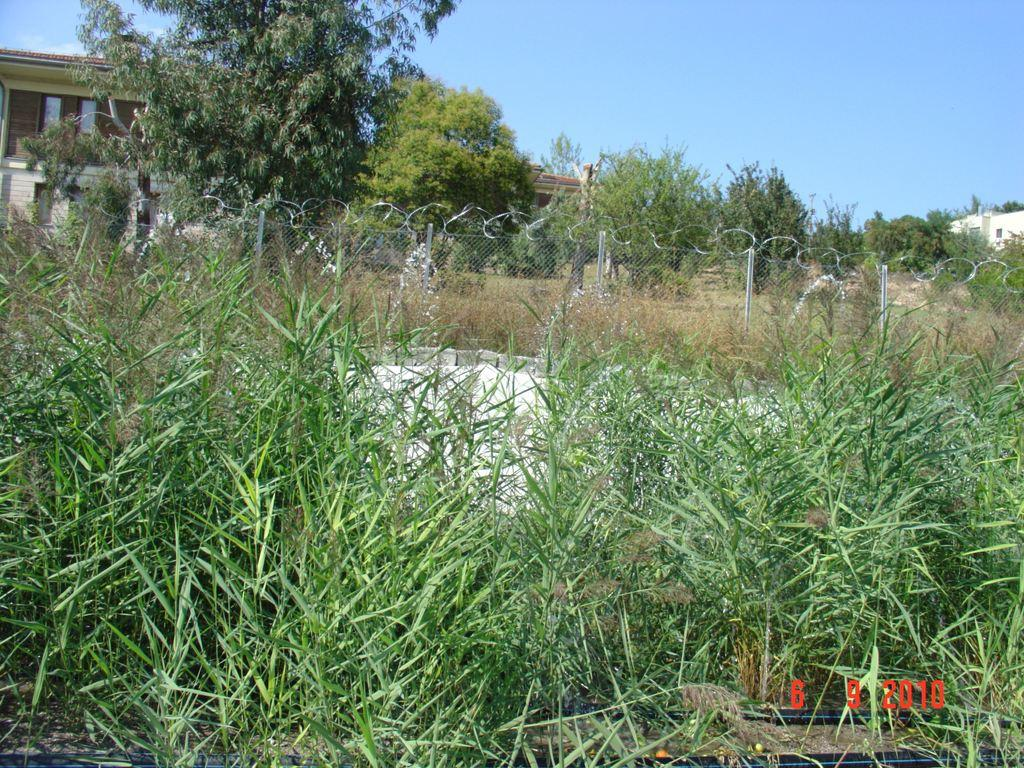What type of vegetation is present in the image? There are trees in the image. Where is the house located in the image? The house is on the left side of the image. What is visible at the top of the image? The sky is visible at the top of the image. What suggestion does the tree make to the house in the image? There is no suggestion being made by the tree to the house in the image, as trees do not communicate in this manner. 